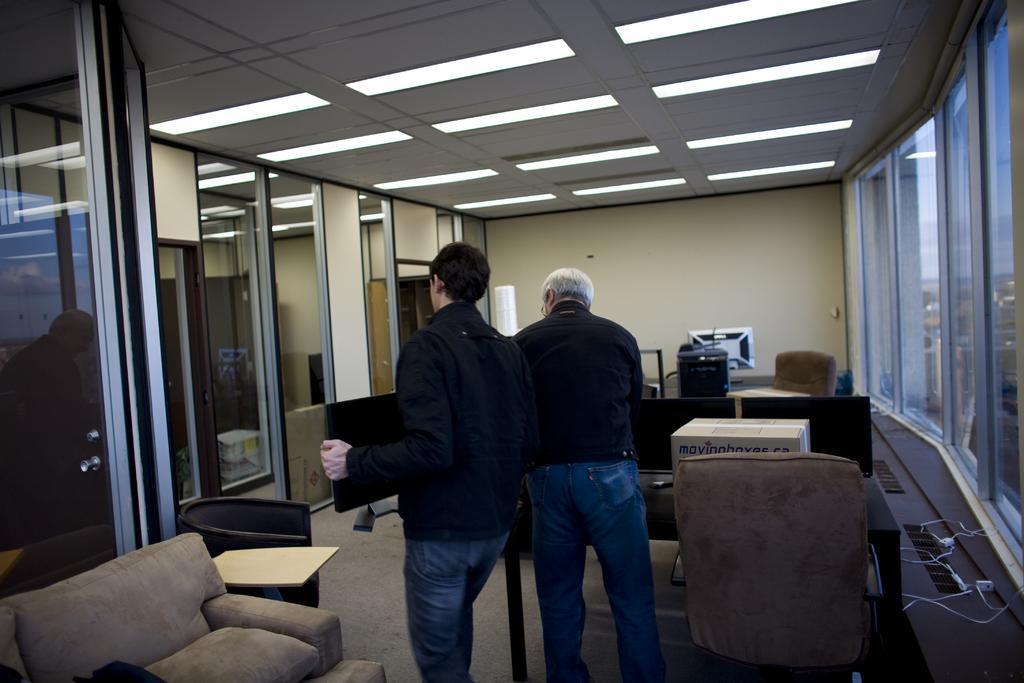In one or two sentences, can you explain what this image depicts? In the picture we can see a room with two men are standing near to each other and one man is holding monitor and one man is doing some work on the table, and on the table, we can see a box and near it, we can see a chair and near to them, we can see a sofa and on the either sides of the room we can see glass walls and to the ceiling we can see the lights. 